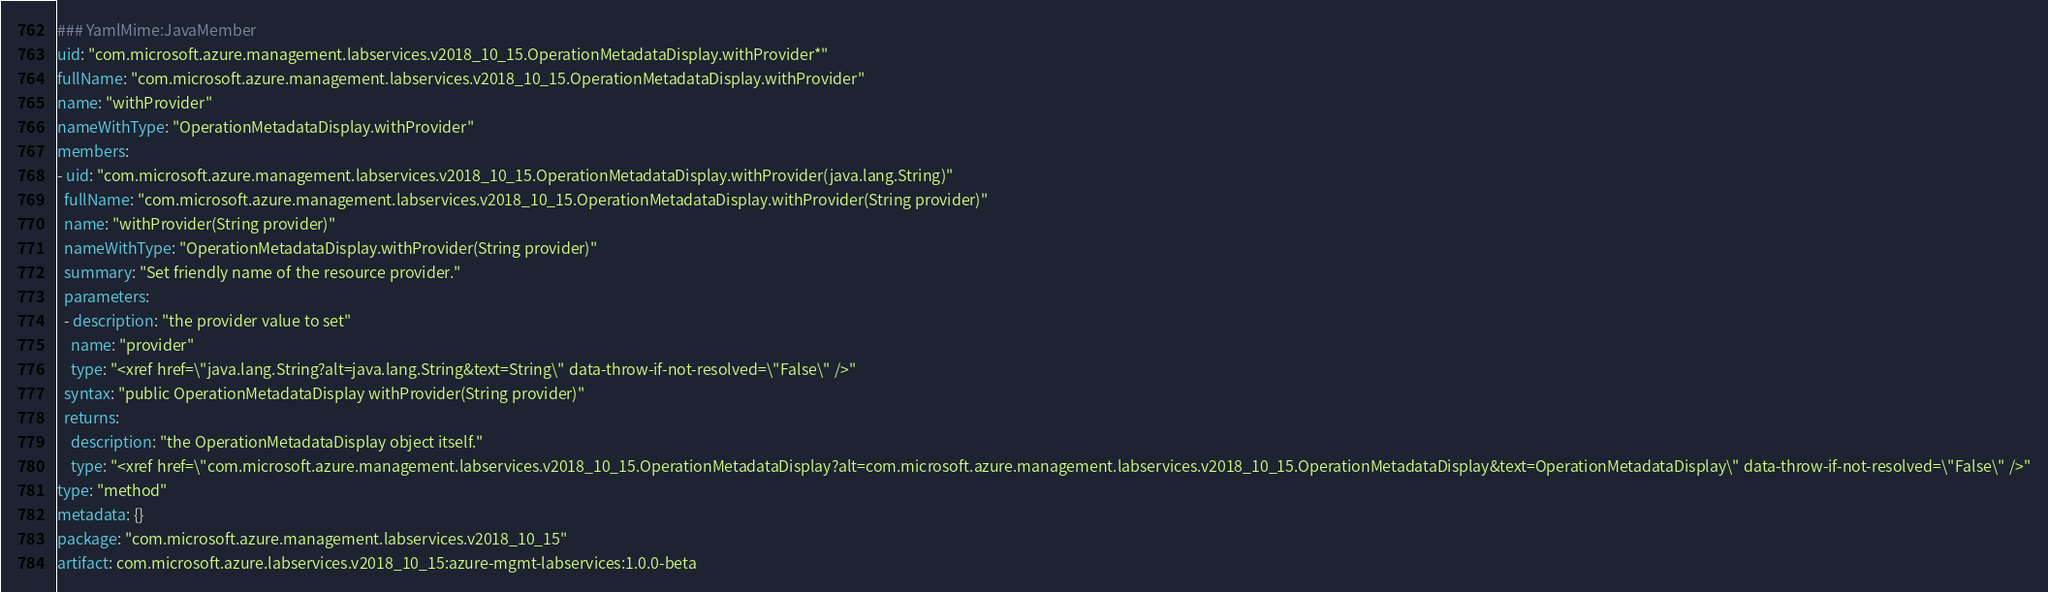<code> <loc_0><loc_0><loc_500><loc_500><_YAML_>### YamlMime:JavaMember
uid: "com.microsoft.azure.management.labservices.v2018_10_15.OperationMetadataDisplay.withProvider*"
fullName: "com.microsoft.azure.management.labservices.v2018_10_15.OperationMetadataDisplay.withProvider"
name: "withProvider"
nameWithType: "OperationMetadataDisplay.withProvider"
members:
- uid: "com.microsoft.azure.management.labservices.v2018_10_15.OperationMetadataDisplay.withProvider(java.lang.String)"
  fullName: "com.microsoft.azure.management.labservices.v2018_10_15.OperationMetadataDisplay.withProvider(String provider)"
  name: "withProvider(String provider)"
  nameWithType: "OperationMetadataDisplay.withProvider(String provider)"
  summary: "Set friendly name of the resource provider."
  parameters:
  - description: "the provider value to set"
    name: "provider"
    type: "<xref href=\"java.lang.String?alt=java.lang.String&text=String\" data-throw-if-not-resolved=\"False\" />"
  syntax: "public OperationMetadataDisplay withProvider(String provider)"
  returns:
    description: "the OperationMetadataDisplay object itself."
    type: "<xref href=\"com.microsoft.azure.management.labservices.v2018_10_15.OperationMetadataDisplay?alt=com.microsoft.azure.management.labservices.v2018_10_15.OperationMetadataDisplay&text=OperationMetadataDisplay\" data-throw-if-not-resolved=\"False\" />"
type: "method"
metadata: {}
package: "com.microsoft.azure.management.labservices.v2018_10_15"
artifact: com.microsoft.azure.labservices.v2018_10_15:azure-mgmt-labservices:1.0.0-beta
</code> 